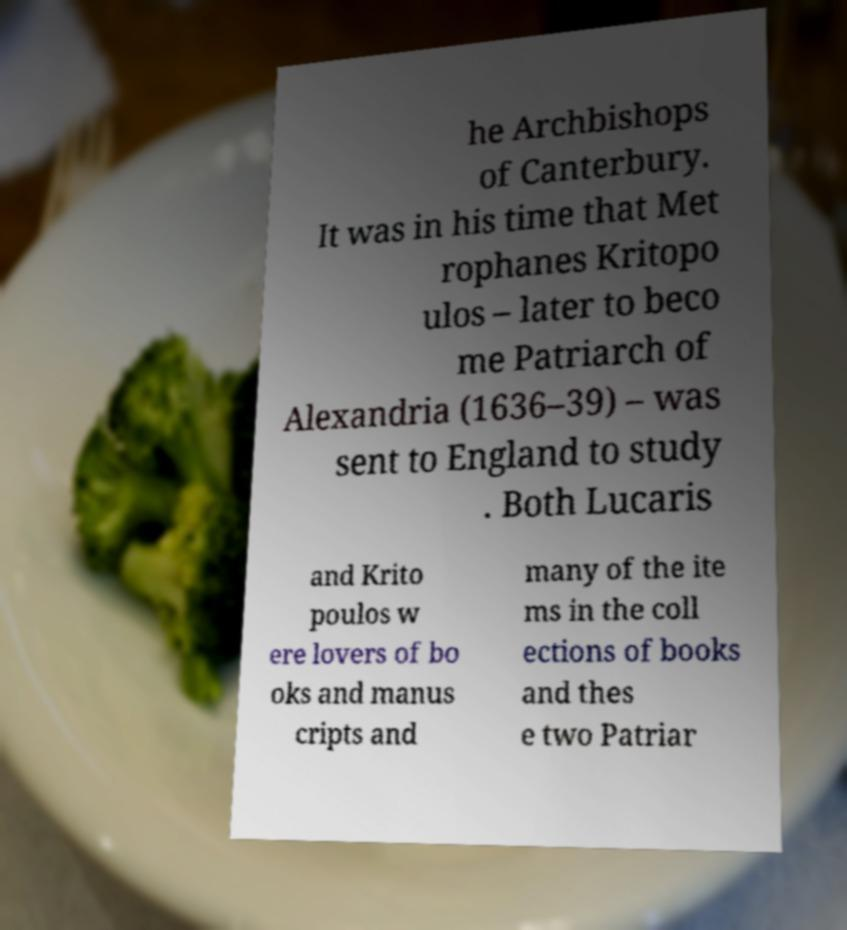Can you read and provide the text displayed in the image?This photo seems to have some interesting text. Can you extract and type it out for me? he Archbishops of Canterbury. It was in his time that Met rophanes Kritopo ulos – later to beco me Patriarch of Alexandria (1636–39) – was sent to England to study . Both Lucaris and Krito poulos w ere lovers of bo oks and manus cripts and many of the ite ms in the coll ections of books and thes e two Patriar 